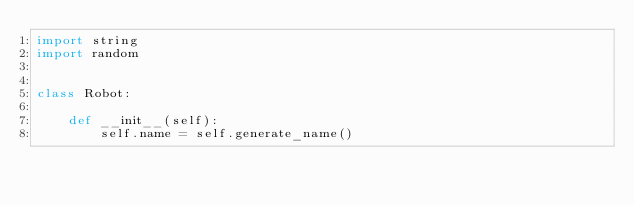Convert code to text. <code><loc_0><loc_0><loc_500><loc_500><_Python_>import string
import random


class Robot:

    def __init__(self):
        self.name = self.generate_name()
</code> 